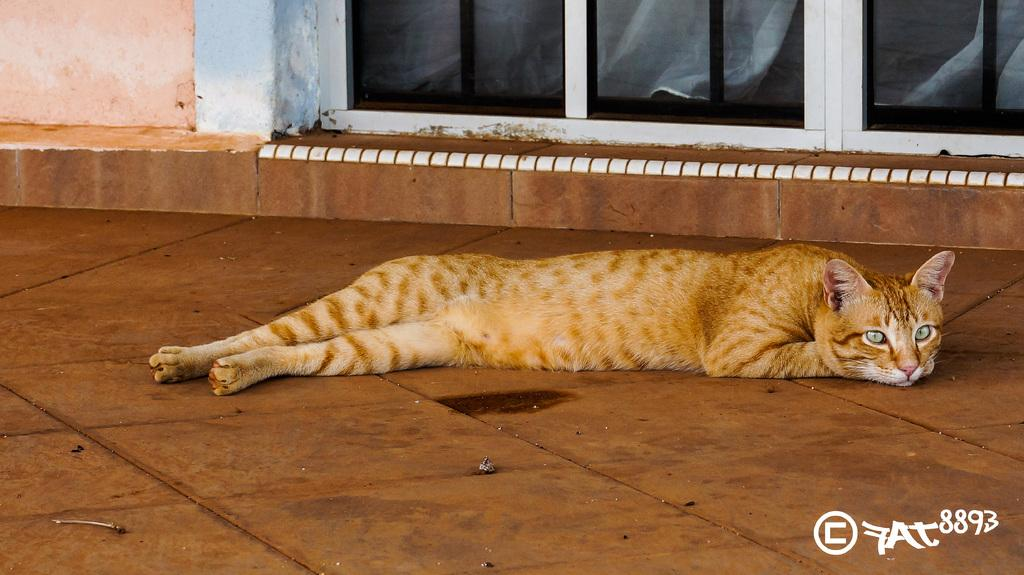What animal can be seen in the image? There is a cat in the image. What is the cat doing in the image? The cat is lying on the floor. What can be seen in the background of the image? There is a door and a wall in the background of the image. How many scarves are being used by the cat in the image? There are no scarves present in the image, and the cat is not using any. 